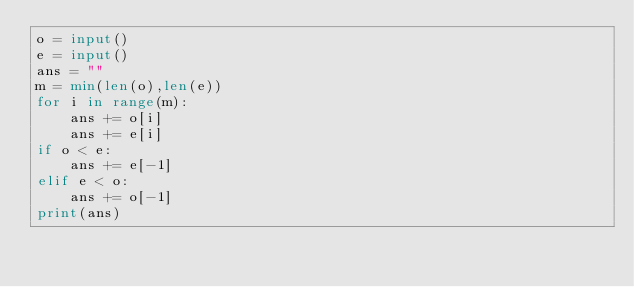Convert code to text. <code><loc_0><loc_0><loc_500><loc_500><_Python_>o = input()
e = input()
ans = ""
m = min(len(o),len(e))
for i in range(m):
    ans += o[i]
    ans += e[i]
if o < e:
    ans += e[-1]
elif e < o:
    ans += o[-1]
print(ans)</code> 